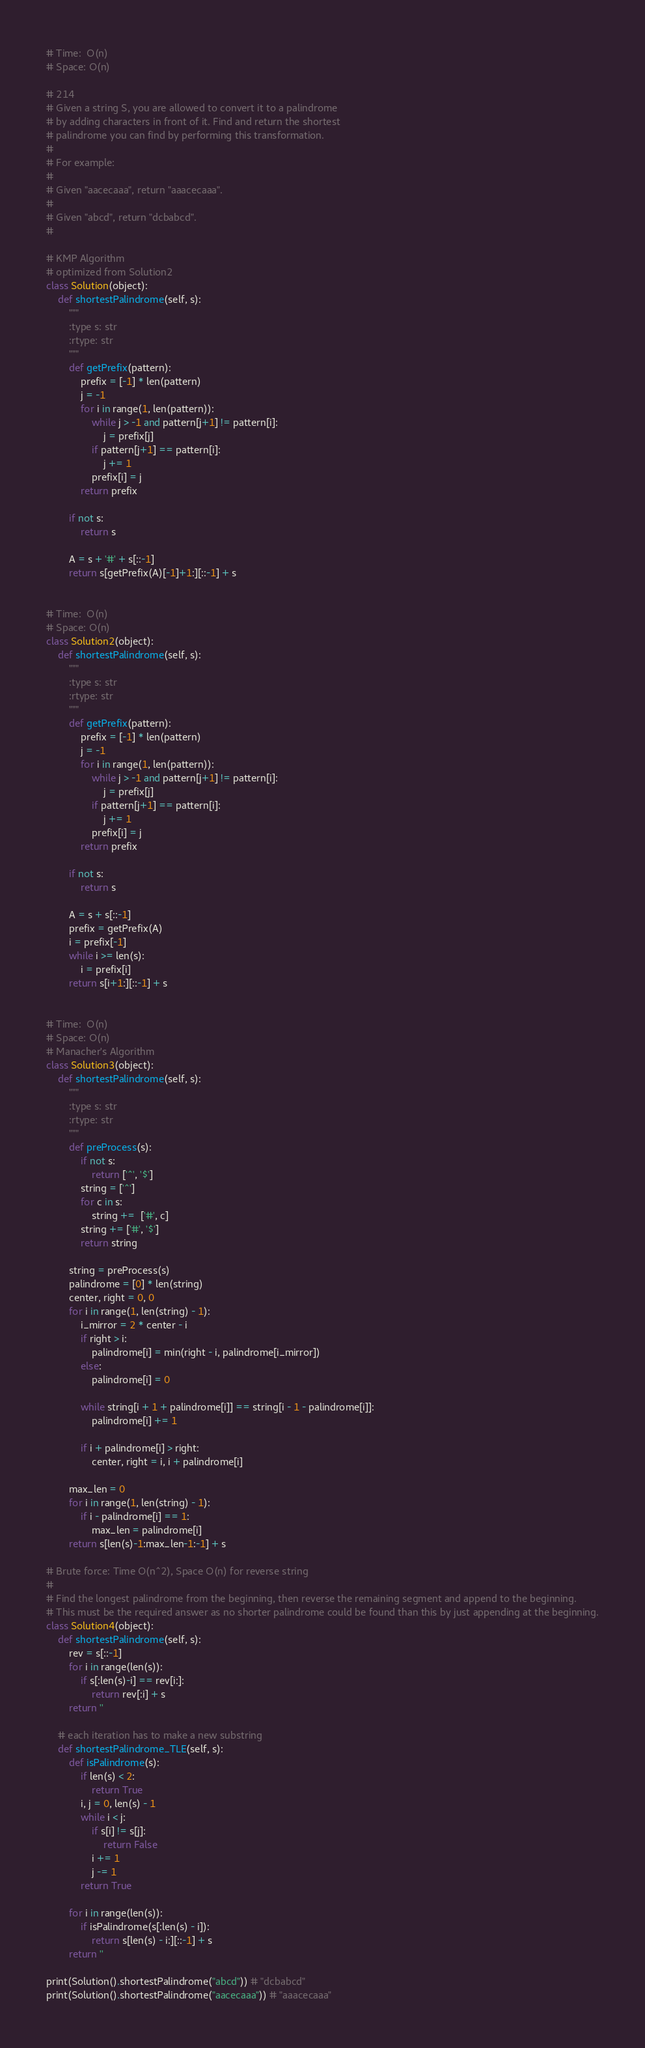<code> <loc_0><loc_0><loc_500><loc_500><_Python_># Time:  O(n)
# Space: O(n)

# 214
# Given a string S, you are allowed to convert it to a palindrome
# by adding characters in front of it. Find and return the shortest
# palindrome you can find by performing this transformation.
#
# For example:
#
# Given "aacecaaa", return "aaacecaaa".
#
# Given "abcd", return "dcbabcd".
#

# KMP Algorithm
# optimized from Solution2
class Solution(object):
    def shortestPalindrome(self, s):
        """
        :type s: str
        :rtype: str
        """
        def getPrefix(pattern):
            prefix = [-1] * len(pattern)
            j = -1
            for i in range(1, len(pattern)):
                while j > -1 and pattern[j+1] != pattern[i]:
                    j = prefix[j]
                if pattern[j+1] == pattern[i]:
                    j += 1
                prefix[i] = j
            return prefix

        if not s:
            return s

        A = s + '#' + s[::-1]
        return s[getPrefix(A)[-1]+1:][::-1] + s


# Time:  O(n)
# Space: O(n)
class Solution2(object):
    def shortestPalindrome(self, s):
        """
        :type s: str
        :rtype: str
        """
        def getPrefix(pattern):
            prefix = [-1] * len(pattern)
            j = -1
            for i in range(1, len(pattern)):
                while j > -1 and pattern[j+1] != pattern[i]:
                    j = prefix[j]
                if pattern[j+1] == pattern[i]:
                    j += 1
                prefix[i] = j
            return prefix

        if not s:
            return s

        A = s + s[::-1]
        prefix = getPrefix(A)
        i = prefix[-1]
        while i >= len(s):
            i = prefix[i]
        return s[i+1:][::-1] + s


# Time:  O(n)
# Space: O(n)
# Manacher's Algorithm
class Solution3(object):
    def shortestPalindrome(self, s):
        """
        :type s: str
        :rtype: str
        """
        def preProcess(s):
            if not s:
                return ['^', '$']
            string = ['^']
            for c in s:
                string +=  ['#', c]
            string += ['#', '$']
            return string

        string = preProcess(s)
        palindrome = [0] * len(string)
        center, right = 0, 0
        for i in range(1, len(string) - 1):
            i_mirror = 2 * center - i
            if right > i:
                palindrome[i] = min(right - i, palindrome[i_mirror])
            else:
                palindrome[i] = 0

            while string[i + 1 + palindrome[i]] == string[i - 1 - palindrome[i]]:
                palindrome[i] += 1

            if i + palindrome[i] > right:
                center, right = i, i + palindrome[i]

        max_len = 0
        for i in range(1, len(string) - 1):
            if i - palindrome[i] == 1:
                max_len = palindrome[i]
        return s[len(s)-1:max_len-1:-1] + s

# Brute force: Time O(n^2), Space O(n) for reverse string
#
# Find the longest palindrome from the beginning, then reverse the remaining segment and append to the beginning.
# This must be the required answer as no shorter palindrome could be found than this by just appending at the beginning.
class Solution4(object):
    def shortestPalindrome(self, s):
        rev = s[::-1]
        for i in range(len(s)):
            if s[:len(s)-i] == rev[i:]:
                return rev[:i] + s
        return ''

    # each iteration has to make a new substring
    def shortestPalindrome_TLE(self, s):
        def isPalindrome(s):
            if len(s) < 2:
                return True
            i, j = 0, len(s) - 1
            while i < j:
                if s[i] != s[j]:
                    return False
                i += 1
                j -= 1
            return True

        for i in range(len(s)):
            if isPalindrome(s[:len(s) - i]):
                return s[len(s) - i:][::-1] + s
        return ''

print(Solution().shortestPalindrome("abcd")) # "dcbabcd"
print(Solution().shortestPalindrome("aacecaaa")) # "aaacecaaa"
</code> 